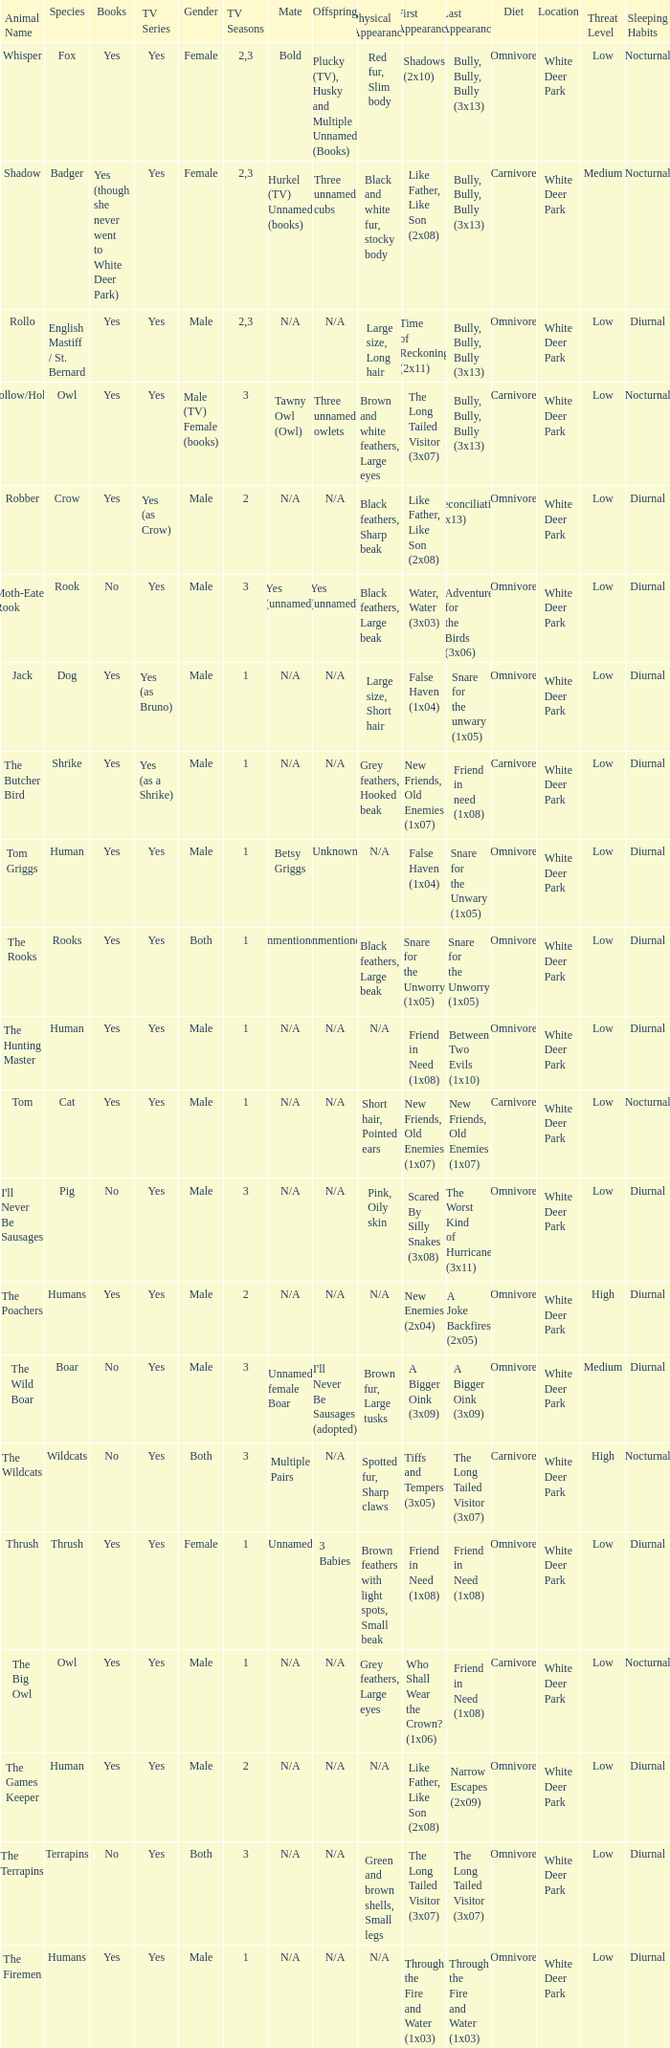What animal was yes for tv series and was a terrapins? The Terrapins. Give me the full table as a dictionary. {'header': ['Animal Name', 'Species', 'Books', 'TV Series', 'Gender', 'TV Seasons', 'Mate', 'Offspring', 'Physical Appearance', 'First Appearance', 'Last Appearance', 'Diet', 'Location', 'Threat Level', 'Sleeping Habits'], 'rows': [['Whisper', 'Fox', 'Yes', 'Yes', 'Female', '2,3', 'Bold', 'Plucky (TV), Husky and Multiple Unnamed (Books)', 'Red fur, Slim body', 'Shadows (2x10)', 'Bully, Bully, Bully (3x13)', 'Omnivore', 'White Deer Park', 'Low', 'Nocturnal'], ['Shadow', 'Badger', 'Yes (though she never went to White Deer Park)', 'Yes', 'Female', '2,3', 'Hurkel (TV) Unnamed (books)', 'Three unnamed cubs', 'Black and white fur, stocky body', 'Like Father, Like Son (2x08)', 'Bully, Bully, Bully (3x13)', 'Carnivore', 'White Deer Park', 'Medium', 'Nocturnal'], ['Rollo', 'English Mastiff / St. Bernard', 'Yes', 'Yes', 'Male', '2,3', 'N/A', 'N/A', 'Large size, Long hair', 'Time of Reckoning (2x11)', 'Bully, Bully, Bully (3x13)', 'Omnivore', 'White Deer Park', 'Low', 'Diurnal'], ['Hollow/Holly', 'Owl', 'Yes', 'Yes', 'Male (TV) Female (books)', '3', 'Tawny Owl (Owl)', 'Three unnamed owlets', 'Brown and white feathers, Large eyes', 'The Long Tailed Visitor (3x07)', 'Bully, Bully, Bully (3x13)', 'Carnivore', 'White Deer Park', 'Low', 'Nocturnal'], ['Robber', 'Crow', 'Yes', 'Yes (as Crow)', 'Male', '2', 'N/A', 'N/A', 'Black feathers, Sharp beak', 'Like Father, Like Son (2x08)', 'Reconciliation (2x13)', 'Omnivore', 'White Deer Park', 'Low', 'Diurnal'], ['Moth-Eaten Rook', 'Rook', 'No', 'Yes', 'Male', '3', 'Yes (unnamed)', 'Yes (unnamed)', 'Black feathers, Large beak', 'Water, Water (3x03)', 'Adventure for the Birds (3x06)', 'Omnivore', 'White Deer Park', 'Low', 'Diurnal'], ['Jack', 'Dog', 'Yes', 'Yes (as Bruno)', 'Male', '1', 'N/A', 'N/A', 'Large size, Short hair', 'False Haven (1x04)', 'Snare for the unwary (1x05)', 'Omnivore', 'White Deer Park', 'Low', 'Diurnal'], ['The Butcher Bird', 'Shrike', 'Yes', 'Yes (as a Shrike)', 'Male', '1', 'N/A', 'N/A', 'Grey feathers, Hooked beak', 'New Friends, Old Enemies (1x07)', 'Friend in need (1x08)', 'Carnivore', 'White Deer Park', 'Low', 'Diurnal'], ['Tom Griggs', 'Human', 'Yes', 'Yes', 'Male', '1', 'Betsy Griggs', 'Unknown', 'N/A', 'False Haven (1x04)', 'Snare for the Unwary (1x05)', 'Omnivore', 'White Deer Park', 'Low', 'Diurnal'], ['The Rooks', 'Rooks', 'Yes', 'Yes', 'Both', '1', 'Unmentioned', 'Unmentioned', 'Black feathers, Large beak', 'Snare for the Unworry (1x05)', 'Snare for the Unworry (1x05)', 'Omnivore', 'White Deer Park', 'Low', 'Diurnal'], ['The Hunting Master', 'Human', 'Yes', 'Yes', 'Male', '1', 'N/A', 'N/A', 'N/A', 'Friend in Need (1x08)', 'Between Two Evils (1x10)', 'Omnivore', 'White Deer Park', 'Low', 'Diurnal'], ['Tom', 'Cat', 'Yes', 'Yes', 'Male', '1', 'N/A', 'N/A', 'Short hair, Pointed ears', 'New Friends, Old Enemies (1x07)', 'New Friends, Old Enemies (1x07)', 'Carnivore', 'White Deer Park', 'Low', 'Nocturnal'], ["I'll Never Be Sausages", 'Pig', 'No', 'Yes', 'Male', '3', 'N/A', 'N/A', 'Pink, Oily skin', 'Scared By Silly Snakes (3x08)', 'The Worst Kind of Hurricane (3x11)', 'Omnivore', 'White Deer Park', 'Low', 'Diurnal'], ['The Poachers', 'Humans', 'Yes', 'Yes', 'Male', '2', 'N/A', 'N/A', 'N/A', 'New Enemies (2x04)', 'A Joke Backfires (2x05)', 'Omnivore', 'White Deer Park', 'High', 'Diurnal'], ['The Wild Boar', 'Boar', 'No', 'Yes', 'Male', '3', 'Unnamed female Boar', "I'll Never Be Sausages (adopted)", 'Brown fur, Large tusks', 'A Bigger Oink (3x09)', 'A Bigger Oink (3x09)', 'Omnivore', 'White Deer Park', 'Medium', 'Diurnal'], ['The Wildcats', 'Wildcats', 'No', 'Yes', 'Both', '3', 'Multiple Pairs', 'N/A', 'Spotted fur, Sharp claws', 'Tiffs and Tempers (3x05)', 'The Long Tailed Visitor (3x07)', 'Carnivore', 'White Deer Park', 'High', 'Nocturnal'], ['Thrush', 'Thrush', 'Yes', 'Yes', 'Female', '1', 'Unnamed', '3 Babies', 'Brown feathers with light spots, Small beak', 'Friend in Need (1x08)', 'Friend in Need (1x08)', 'Omnivore', 'White Deer Park', 'Low', 'Diurnal'], ['The Big Owl', 'Owl', 'Yes', 'Yes', 'Male', '1', 'N/A', 'N/A', 'Grey feathers, Large eyes', 'Who Shall Wear the Crown? (1x06)', 'Friend in Need (1x08)', 'Carnivore', 'White Deer Park', 'Low', 'Nocturnal'], ['The Games Keeper', 'Human', 'Yes', 'Yes', 'Male', '2', 'N/A', 'N/A', 'N/A', 'Like Father, Like Son (2x08)', 'Narrow Escapes (2x09)', 'Omnivore', 'White Deer Park', 'Low', 'Diurnal'], ['The Terrapins', 'Terrapins', 'No', 'Yes', 'Both', '3', 'N/A', 'N/A', 'Green and brown shells, Small legs', 'The Long Tailed Visitor (3x07)', 'The Long Tailed Visitor (3x07)', 'Omnivore', 'White Deer Park', 'Low', 'Diurnal'], ['The Firemen', 'Humans', 'Yes', 'Yes', 'Male', '1', 'N/A', 'N/A', 'N/A', 'Through the Fire and Water (1x03)', 'Through the Fire and Water (1x03)', 'Omnivore', 'White Deer Park', 'Low', 'Diurnal']]} 